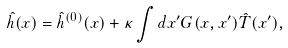Convert formula to latex. <formula><loc_0><loc_0><loc_500><loc_500>\hat { h } ( x ) = \hat { h } ^ { ( 0 ) } ( x ) + \kappa \int d x ^ { \prime } G ( x , x ^ { \prime } ) \hat { T } ( x ^ { \prime } ) ,</formula> 